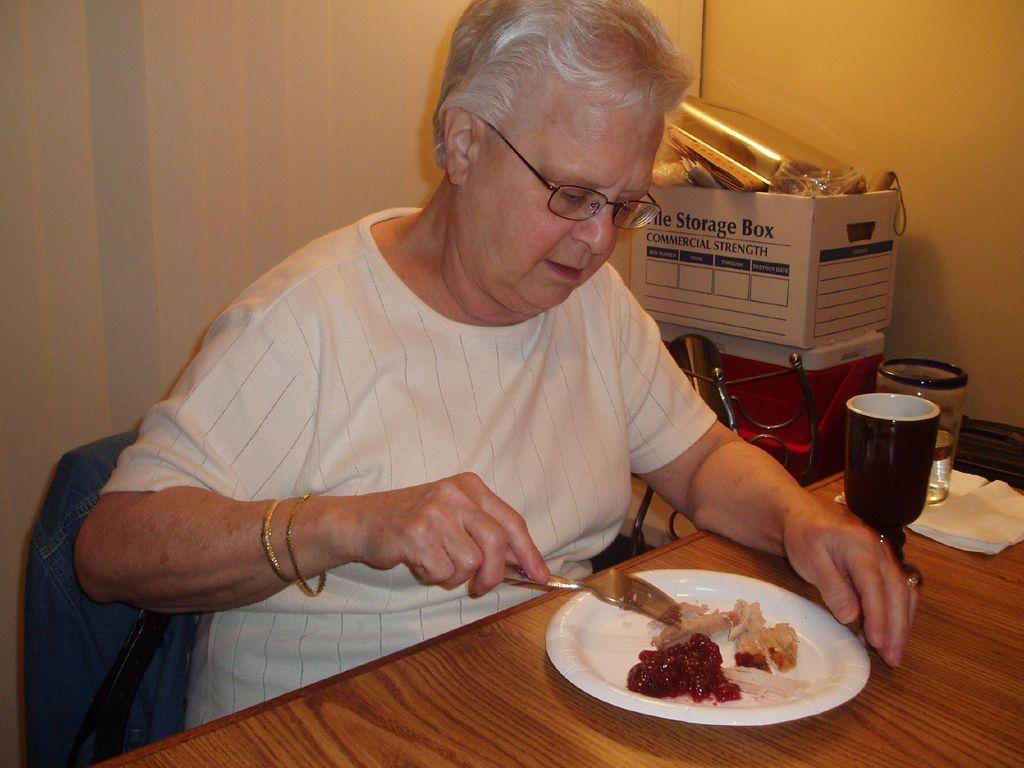Please provide a concise description of this image. In this picture we can see women wore spectacle, bangles holding fork in her hand and in front of her there is table and on table we can see plate with food in it, glass, tissue paper and in background we can see box, wall. 